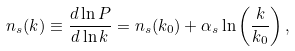Convert formula to latex. <formula><loc_0><loc_0><loc_500><loc_500>n _ { s } ( k ) \equiv \frac { d \ln P } { d \ln k } = n _ { s } ( k _ { 0 } ) + \alpha _ { s } \ln \left ( \frac { k } { k _ { 0 } } \right ) ,</formula> 